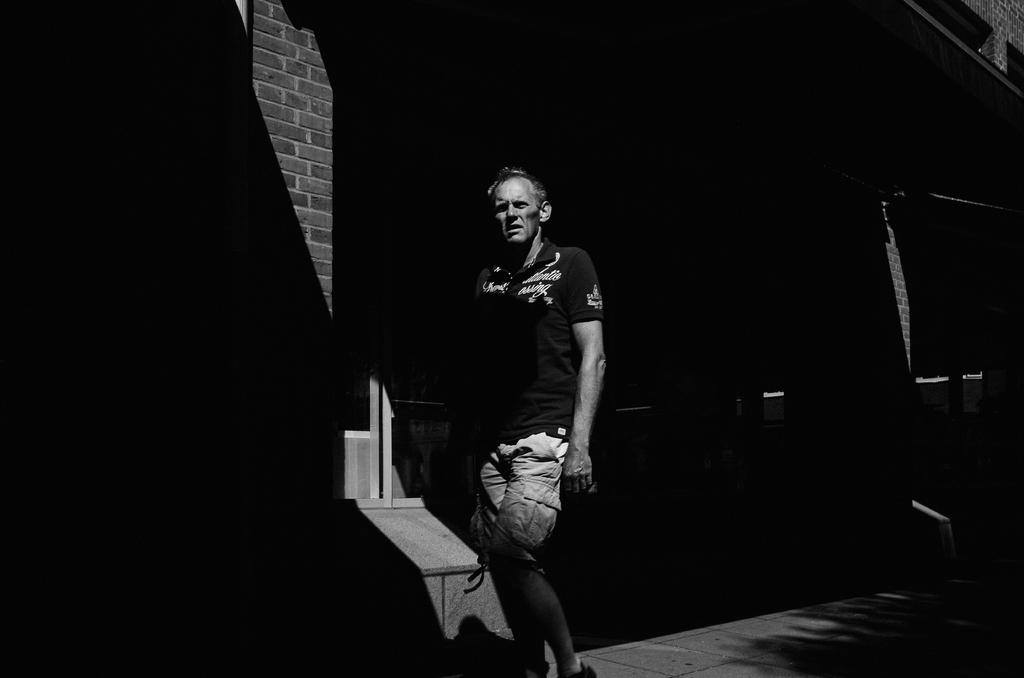What is the main subject of the image? There is a person in the image. What is the person wearing? The person is wearing a t-shirt. What activity is the person engaged in? The person is walking on a footpath. What can be seen in the background of the image? There is a building in the background of the image. What is the building made of? The building has a brick wall. Is the person's mom holding an umbrella for them in the image? There is no mention of an umbrella or the person's mom in the image, so we cannot answer this question. 